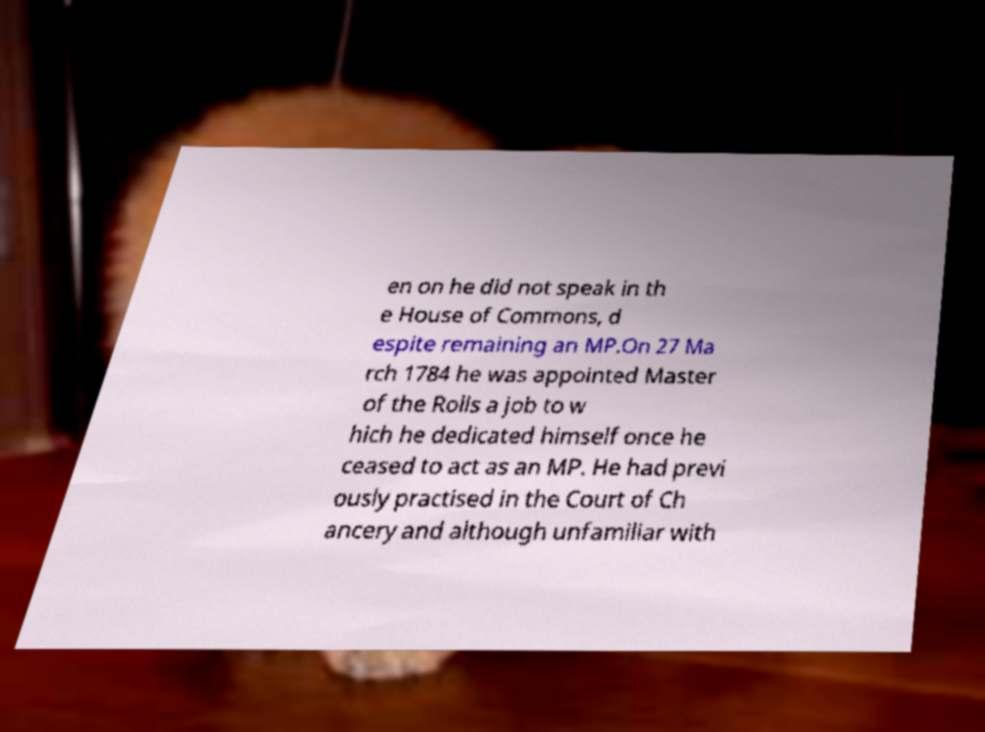Please read and relay the text visible in this image. What does it say? en on he did not speak in th e House of Commons, d espite remaining an MP.On 27 Ma rch 1784 he was appointed Master of the Rolls a job to w hich he dedicated himself once he ceased to act as an MP. He had previ ously practised in the Court of Ch ancery and although unfamiliar with 